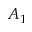Convert formula to latex. <formula><loc_0><loc_0><loc_500><loc_500>A _ { 1 }</formula> 